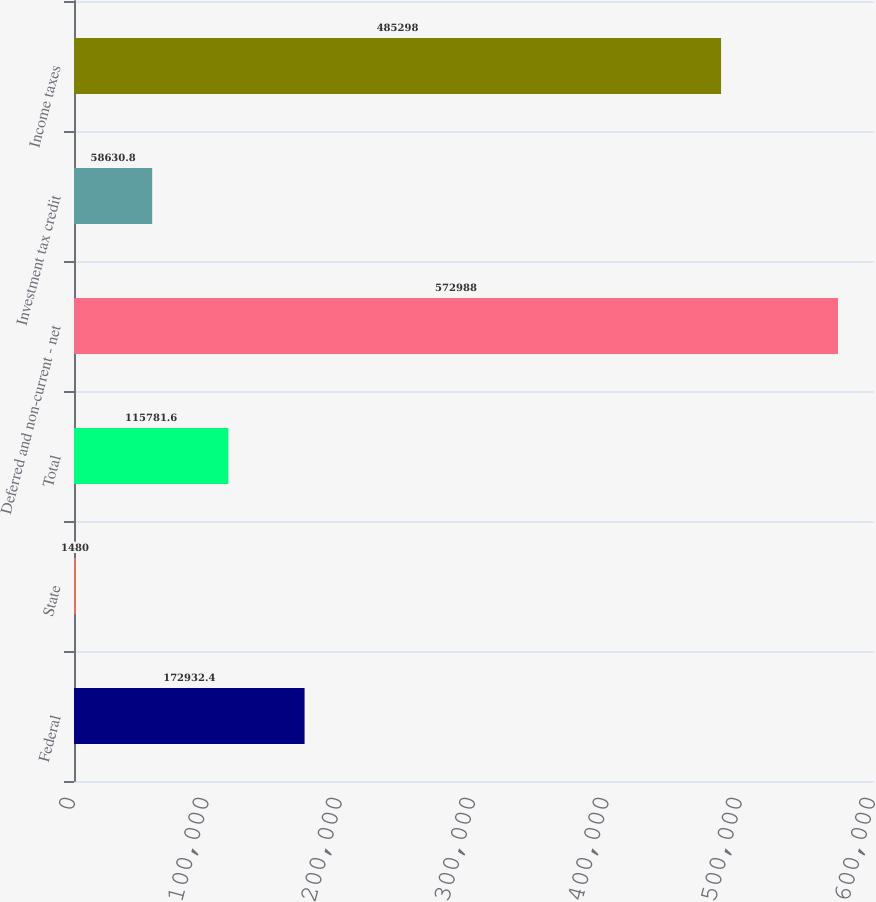Convert chart to OTSL. <chart><loc_0><loc_0><loc_500><loc_500><bar_chart><fcel>Federal<fcel>State<fcel>Total<fcel>Deferred and non-current - net<fcel>Investment tax credit<fcel>Income taxes<nl><fcel>172932<fcel>1480<fcel>115782<fcel>572988<fcel>58630.8<fcel>485298<nl></chart> 